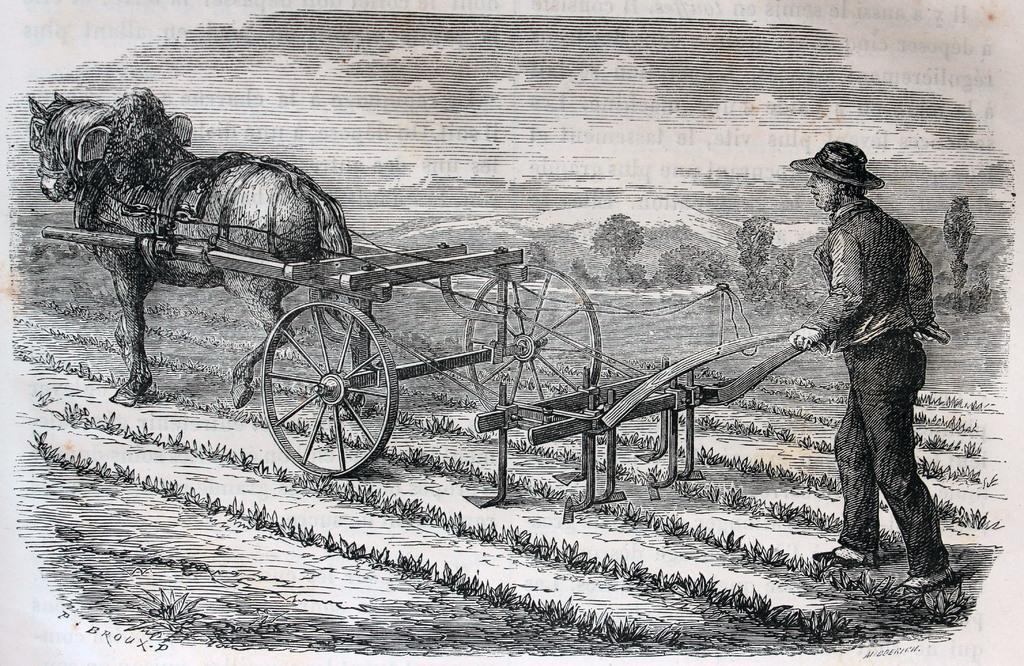Can you describe this image briefly? In this picture I can observe a sketch of a man and a horse ploughing the land. The man is wearing a hat on his head. This is a black and white picture. 